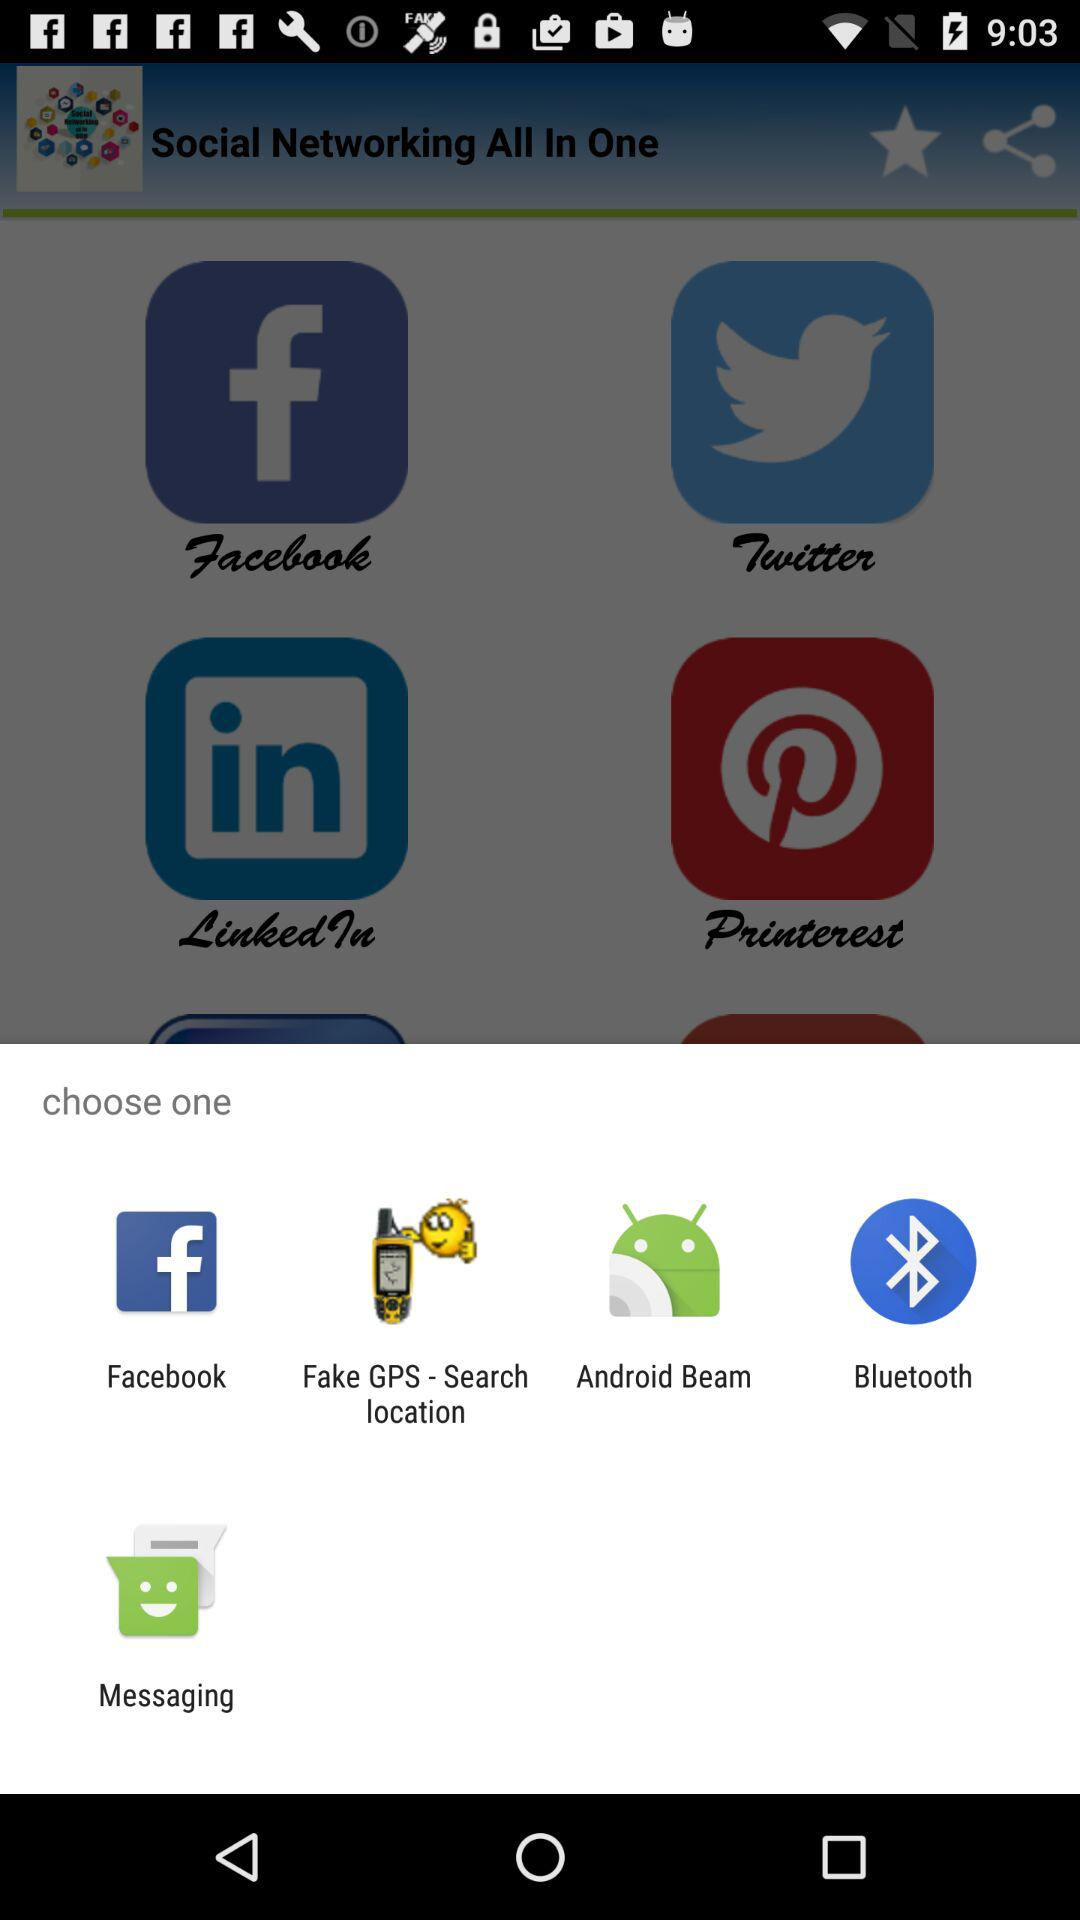Through which option can we share the content? You can share the content through "Facebook", "Fake GPS - Search location", "Android Beam", "Bluetooth" and "Messaging". 